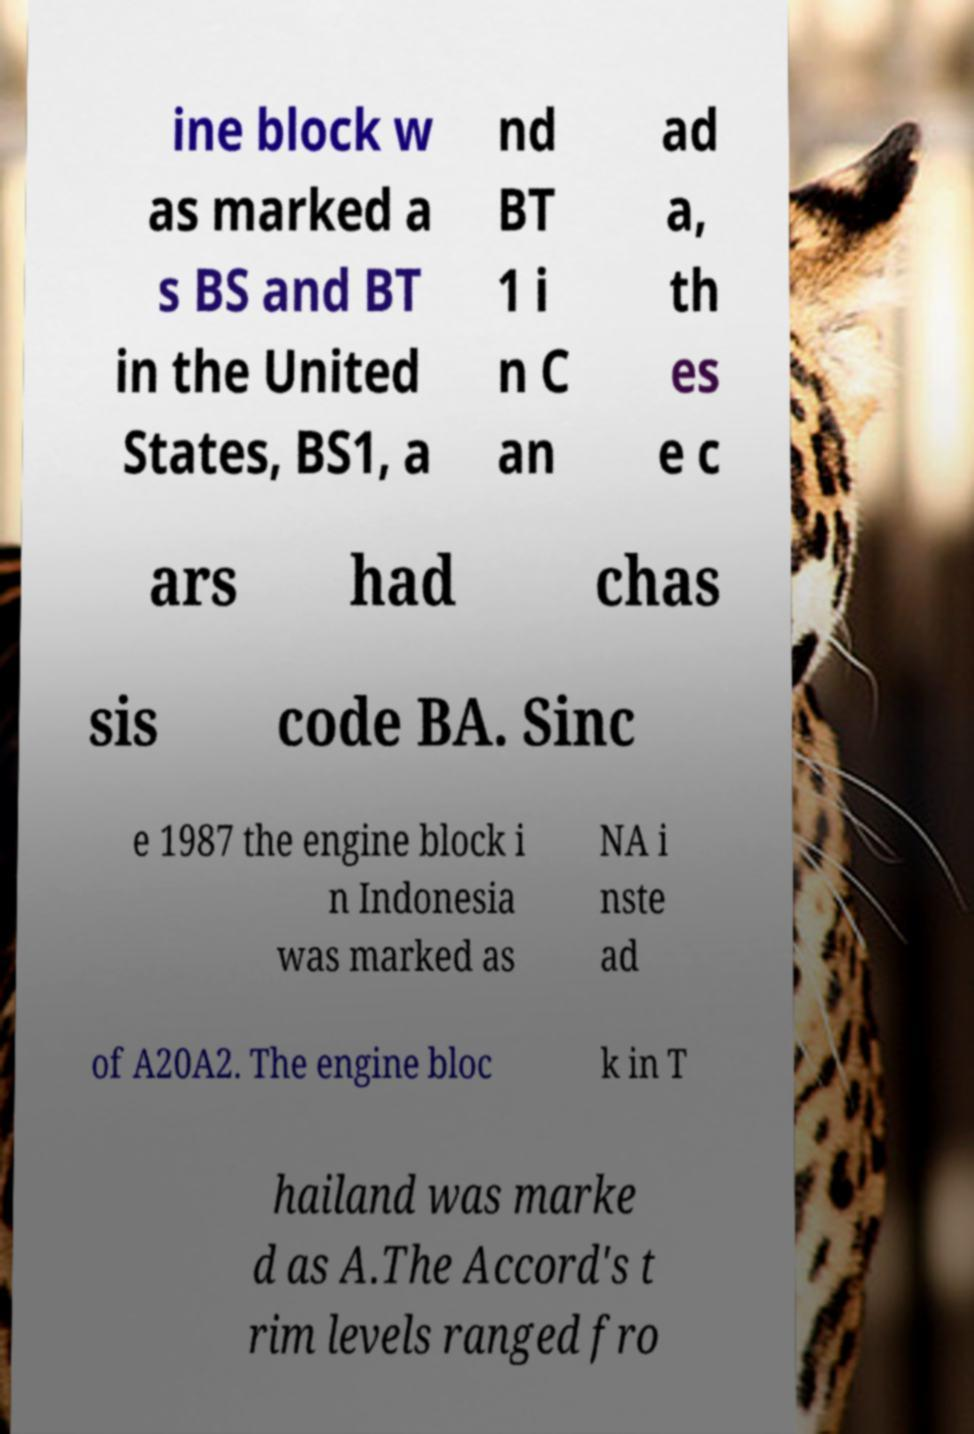There's text embedded in this image that I need extracted. Can you transcribe it verbatim? ine block w as marked a s BS and BT in the United States, BS1, a nd BT 1 i n C an ad a, th es e c ars had chas sis code BA. Sinc e 1987 the engine block i n Indonesia was marked as NA i nste ad of A20A2. The engine bloc k in T hailand was marke d as A.The Accord's t rim levels ranged fro 